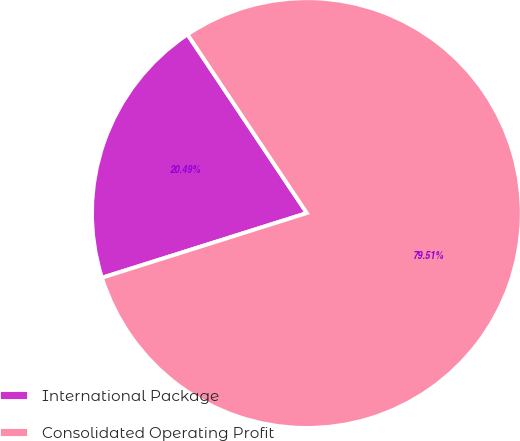Convert chart to OTSL. <chart><loc_0><loc_0><loc_500><loc_500><pie_chart><fcel>International Package<fcel>Consolidated Operating Profit<nl><fcel>20.49%<fcel>79.51%<nl></chart> 